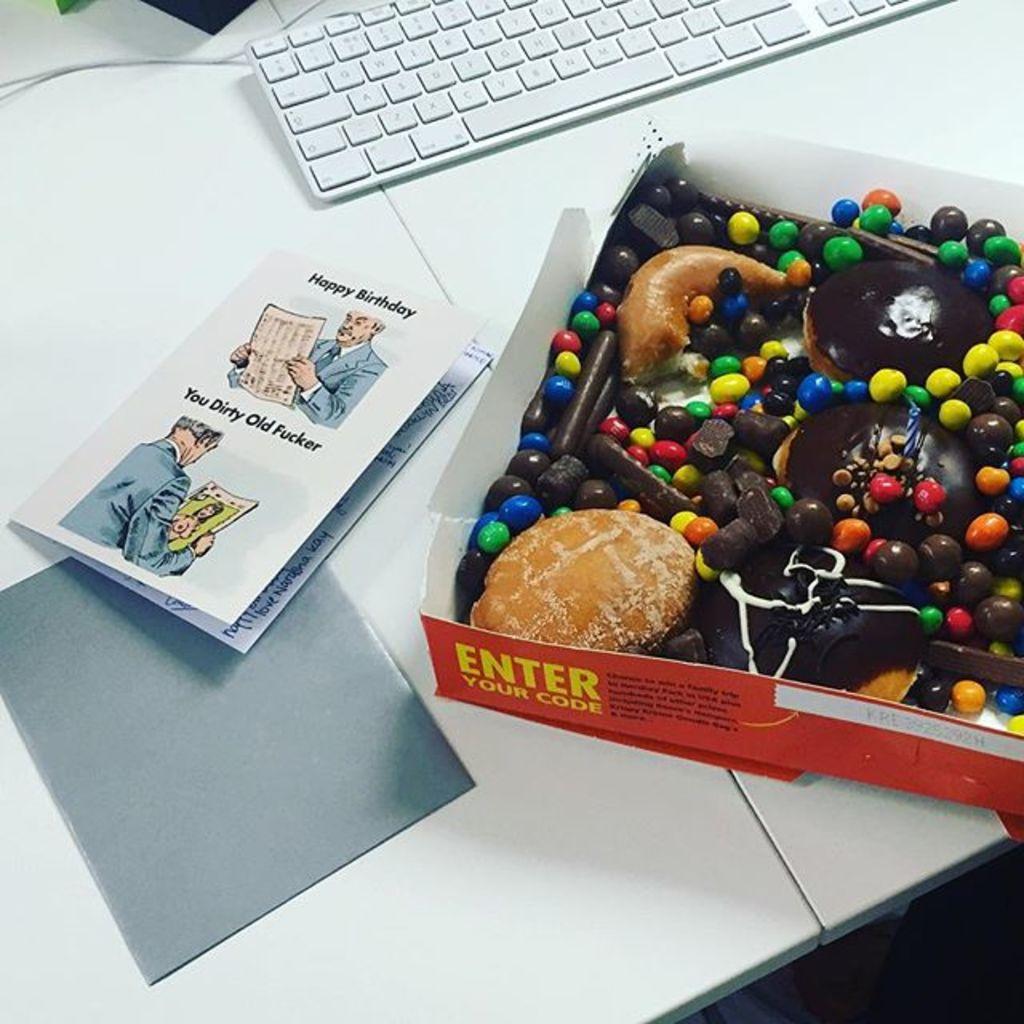Enter my what?
Ensure brevity in your answer.  Code. Is the card a dirt humor birthday card?
Your answer should be compact. Yes. 